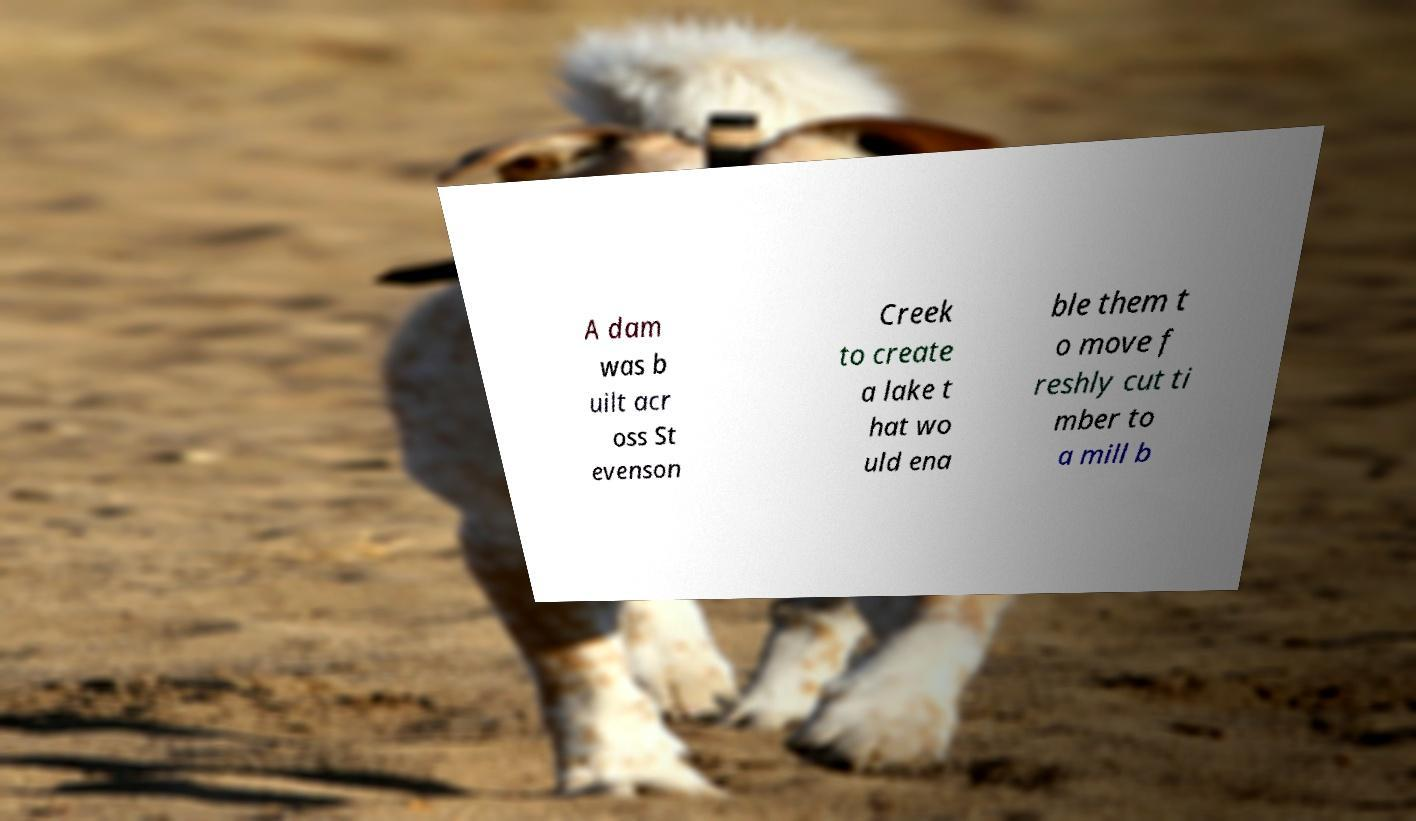There's text embedded in this image that I need extracted. Can you transcribe it verbatim? A dam was b uilt acr oss St evenson Creek to create a lake t hat wo uld ena ble them t o move f reshly cut ti mber to a mill b 